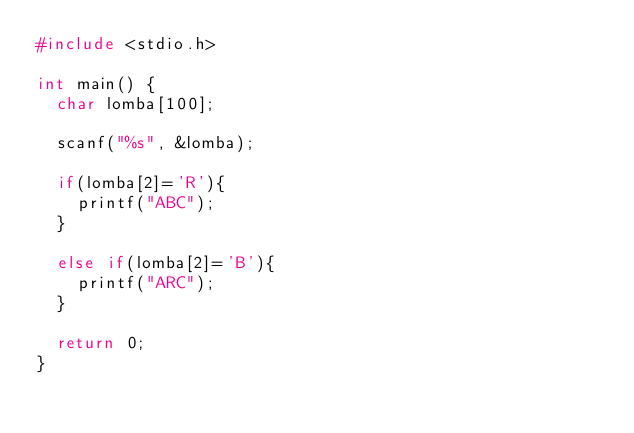Convert code to text. <code><loc_0><loc_0><loc_500><loc_500><_C_>#include <stdio.h>

int main() {
	char lomba[100];
	
	scanf("%s", &lomba);
	
	if(lomba[2]='R'){
		printf("ABC");
	}
	
	else if(lomba[2]='B'){
		printf("ARC");
	}
	
	return 0;
}</code> 